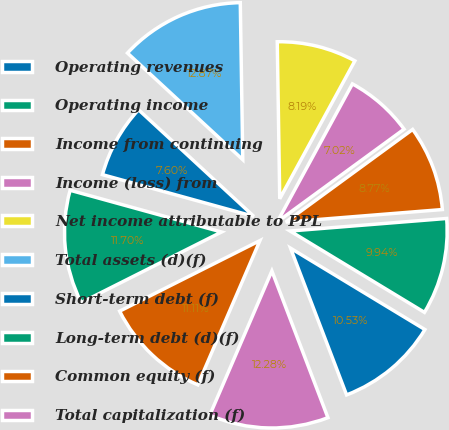<chart> <loc_0><loc_0><loc_500><loc_500><pie_chart><fcel>Operating revenues<fcel>Operating income<fcel>Income from continuing<fcel>Income (loss) from<fcel>Net income attributable to PPL<fcel>Total assets (d)(f)<fcel>Short-term debt (f)<fcel>Long-term debt (d)(f)<fcel>Common equity (f)<fcel>Total capitalization (f)<nl><fcel>10.53%<fcel>9.94%<fcel>8.77%<fcel>7.02%<fcel>8.19%<fcel>12.87%<fcel>7.6%<fcel>11.7%<fcel>11.11%<fcel>12.28%<nl></chart> 